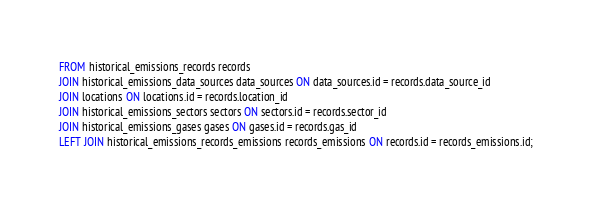<code> <loc_0><loc_0><loc_500><loc_500><_SQL_>FROM historical_emissions_records records
JOIN historical_emissions_data_sources data_sources ON data_sources.id = records.data_source_id
JOIN locations ON locations.id = records.location_id
JOIN historical_emissions_sectors sectors ON sectors.id = records.sector_id
JOIN historical_emissions_gases gases ON gases.id = records.gas_id
LEFT JOIN historical_emissions_records_emissions records_emissions ON records.id = records_emissions.id;
</code> 